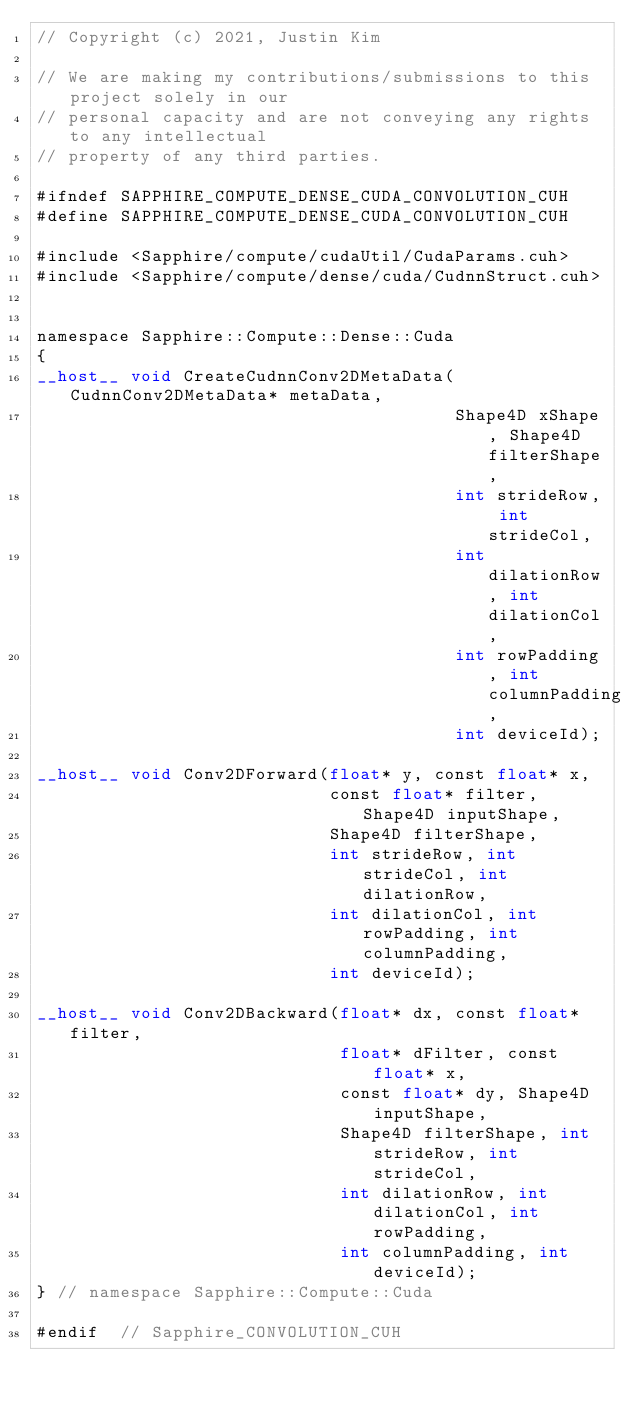Convert code to text. <code><loc_0><loc_0><loc_500><loc_500><_Cuda_>// Copyright (c) 2021, Justin Kim

// We are making my contributions/submissions to this project solely in our
// personal capacity and are not conveying any rights to any intellectual
// property of any third parties.

#ifndef SAPPHIRE_COMPUTE_DENSE_CUDA_CONVOLUTION_CUH
#define SAPPHIRE_COMPUTE_DENSE_CUDA_CONVOLUTION_CUH

#include <Sapphire/compute/cudaUtil/CudaParams.cuh>
#include <Sapphire/compute/dense/cuda/CudnnStruct.cuh>


namespace Sapphire::Compute::Dense::Cuda
{
__host__ void CreateCudnnConv2DMetaData(CudnnConv2DMetaData* metaData,
                                        Shape4D xShape, Shape4D filterShape,
                                        int strideRow, int strideCol,
                                        int dilationRow, int dilationCol,
                                        int rowPadding, int columnPadding,
                                        int deviceId);

__host__ void Conv2DForward(float* y, const float* x,
                            const float* filter, Shape4D inputShape,
                            Shape4D filterShape,
                            int strideRow, int strideCol, int dilationRow,
                            int dilationCol, int rowPadding, int columnPadding,
                            int deviceId);

__host__ void Conv2DBackward(float* dx, const float* filter,
                             float* dFilter, const float* x,
                             const float* dy, Shape4D inputShape,
                             Shape4D filterShape, int strideRow, int strideCol,
                             int dilationRow, int dilationCol, int rowPadding,
                             int columnPadding, int deviceId);
} // namespace Sapphire::Compute::Cuda

#endif  // Sapphire_CONVOLUTION_CUH
</code> 